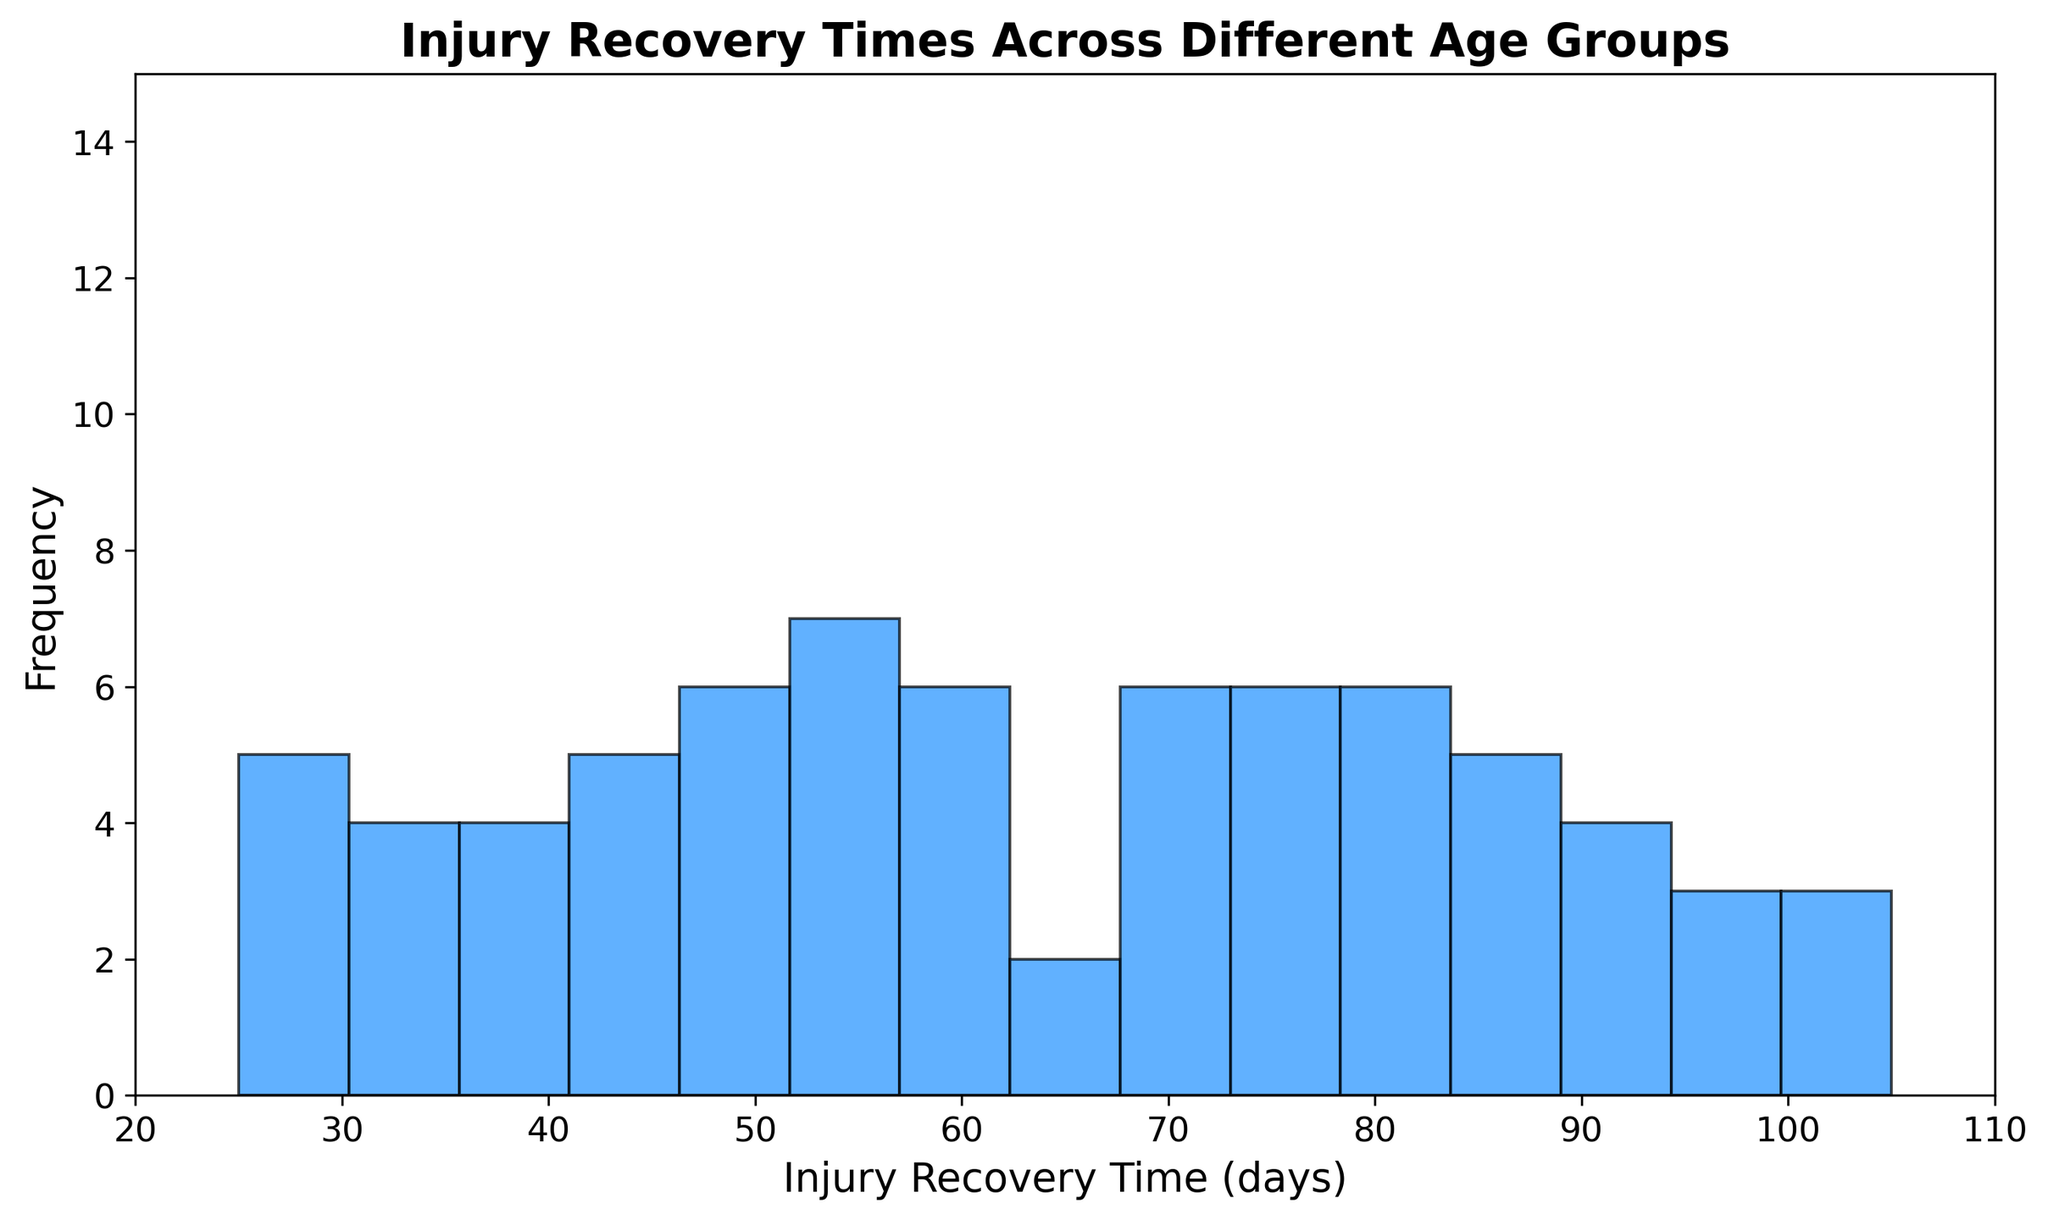How many age groups have the majority of their recovery times clustered around 60 days? To determine how many age groups have most of their recovery times around 60 days, look at the histogram bars near 60 days and count the height of these bars for each age group. The bin near 60 days is notably high, indicating that multiple age groups have a clustering of recovery times around this value.
Answer: Many age groups Is there a significant difference in the number of footballers with injury recovery times less than 50 days compared to those with recovery times greater than 70 days? To assess this, compare the height of the bars to the left of 50 days and to the right of 70 days. Observing the histogram shows fewer high bars on the left side and more high bars on the right side, indicating more footballers have recovery times over 70 days compared to those under 50 days.
Answer: Yes, significant Which range of injury recovery time has the highest frequency of footballers? Identify the tallest bar in the histogram, which corresponds to the range with the highest frequency of footballers. The tallest bar appears between 70 and 80 days, suggesting this range has the highest frequency.
Answer: 70-80 days What is the difference in frequency between the injury recovery time ranges of 50-60 days and 80-90 days? Check the heights of the bars corresponding to the ranges of 50-60 days and 80-90 days. Subtract the frequency of 50-60 days (moderately high) from that of 80-90 days (lower). The frequency in the 50-60 range is higher, making the difference positive.
Answer: Higher by 50-60 days How frequent are the injury recovery times that range between 90 and 100 days? Locate the bars representing the 90-100 days range and observe their heights. The histogram shows two middle-height bars in this range, indicating moderate frequency.
Answer: Moderately frequent How do the injury recovery times of older age groups (30+) compare to those of younger age groups (18-25)? Compare the heights of the bars for age groups 30+ which largely fall in the upper half of the histogram (towards 100), against the younger age groups, which fall lower on the histogram (towards 20-50). Older age groups have longer recovery times.
Answer: Older groups take longer Based on the histogram, is there a consistent trend in injury recovery times as age increases? Observe the positioning of the bars for each age group. As age increases, the bars shift rightwards on the histogram, indicating a trend towards longer recovery times. This suggests older age groups generally take longer to recover.
Answer: Yes Does the histogram suggest any particular age group has uniformly high or low recovery times? Scrutinize if any age group's bars are uniformly high or low in the histogram. Younger age groups (18-25) show lower recovery times (lower bars), while older groups (30+) show higher recovery times (higher bars), indicating a clear distinction.
Answer: Younger: low, Older: high 